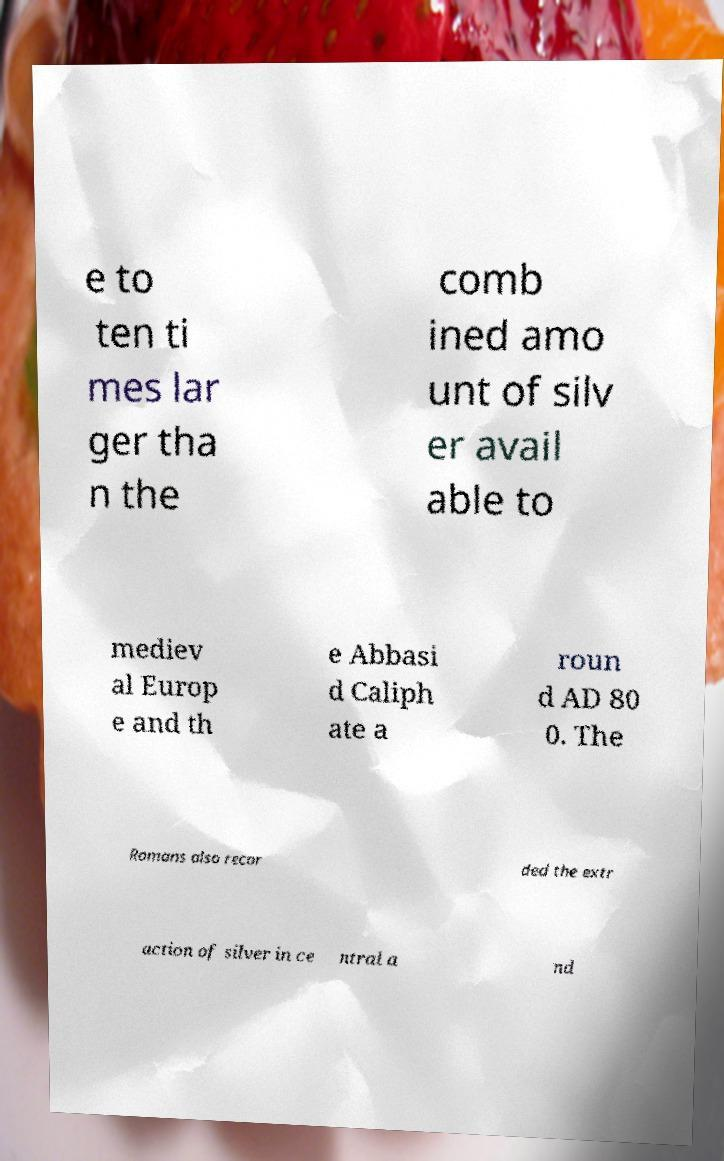Could you extract and type out the text from this image? e to ten ti mes lar ger tha n the comb ined amo unt of silv er avail able to mediev al Europ e and th e Abbasi d Caliph ate a roun d AD 80 0. The Romans also recor ded the extr action of silver in ce ntral a nd 